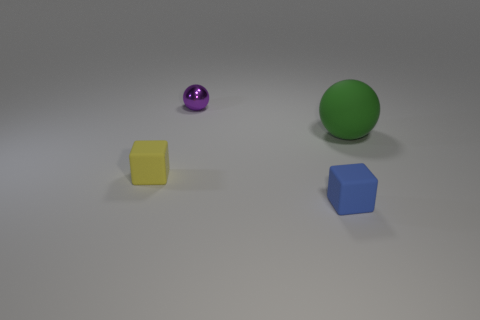Add 1 tiny purple cylinders. How many objects exist? 5 Add 4 large green shiny cylinders. How many large green shiny cylinders exist? 4 Subtract 0 brown blocks. How many objects are left? 4 Subtract all blue objects. Subtract all cyan matte cubes. How many objects are left? 3 Add 3 tiny purple spheres. How many tiny purple spheres are left? 4 